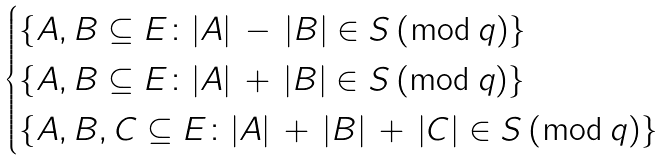<formula> <loc_0><loc_0><loc_500><loc_500>\begin{cases} \{ A , B \subseteq E \colon | A | \, - \, | B | \in S \, ( \bmod \, q ) \} \\ \{ A , B \subseteq E \colon | A | \, + \, | B | \in S \, ( \bmod \, q ) \} \\ \{ A , B , C \subseteq E \colon | A | \, + \, | B | \, + \, | C | \in S \, ( \bmod \, q ) \} \end{cases}</formula> 